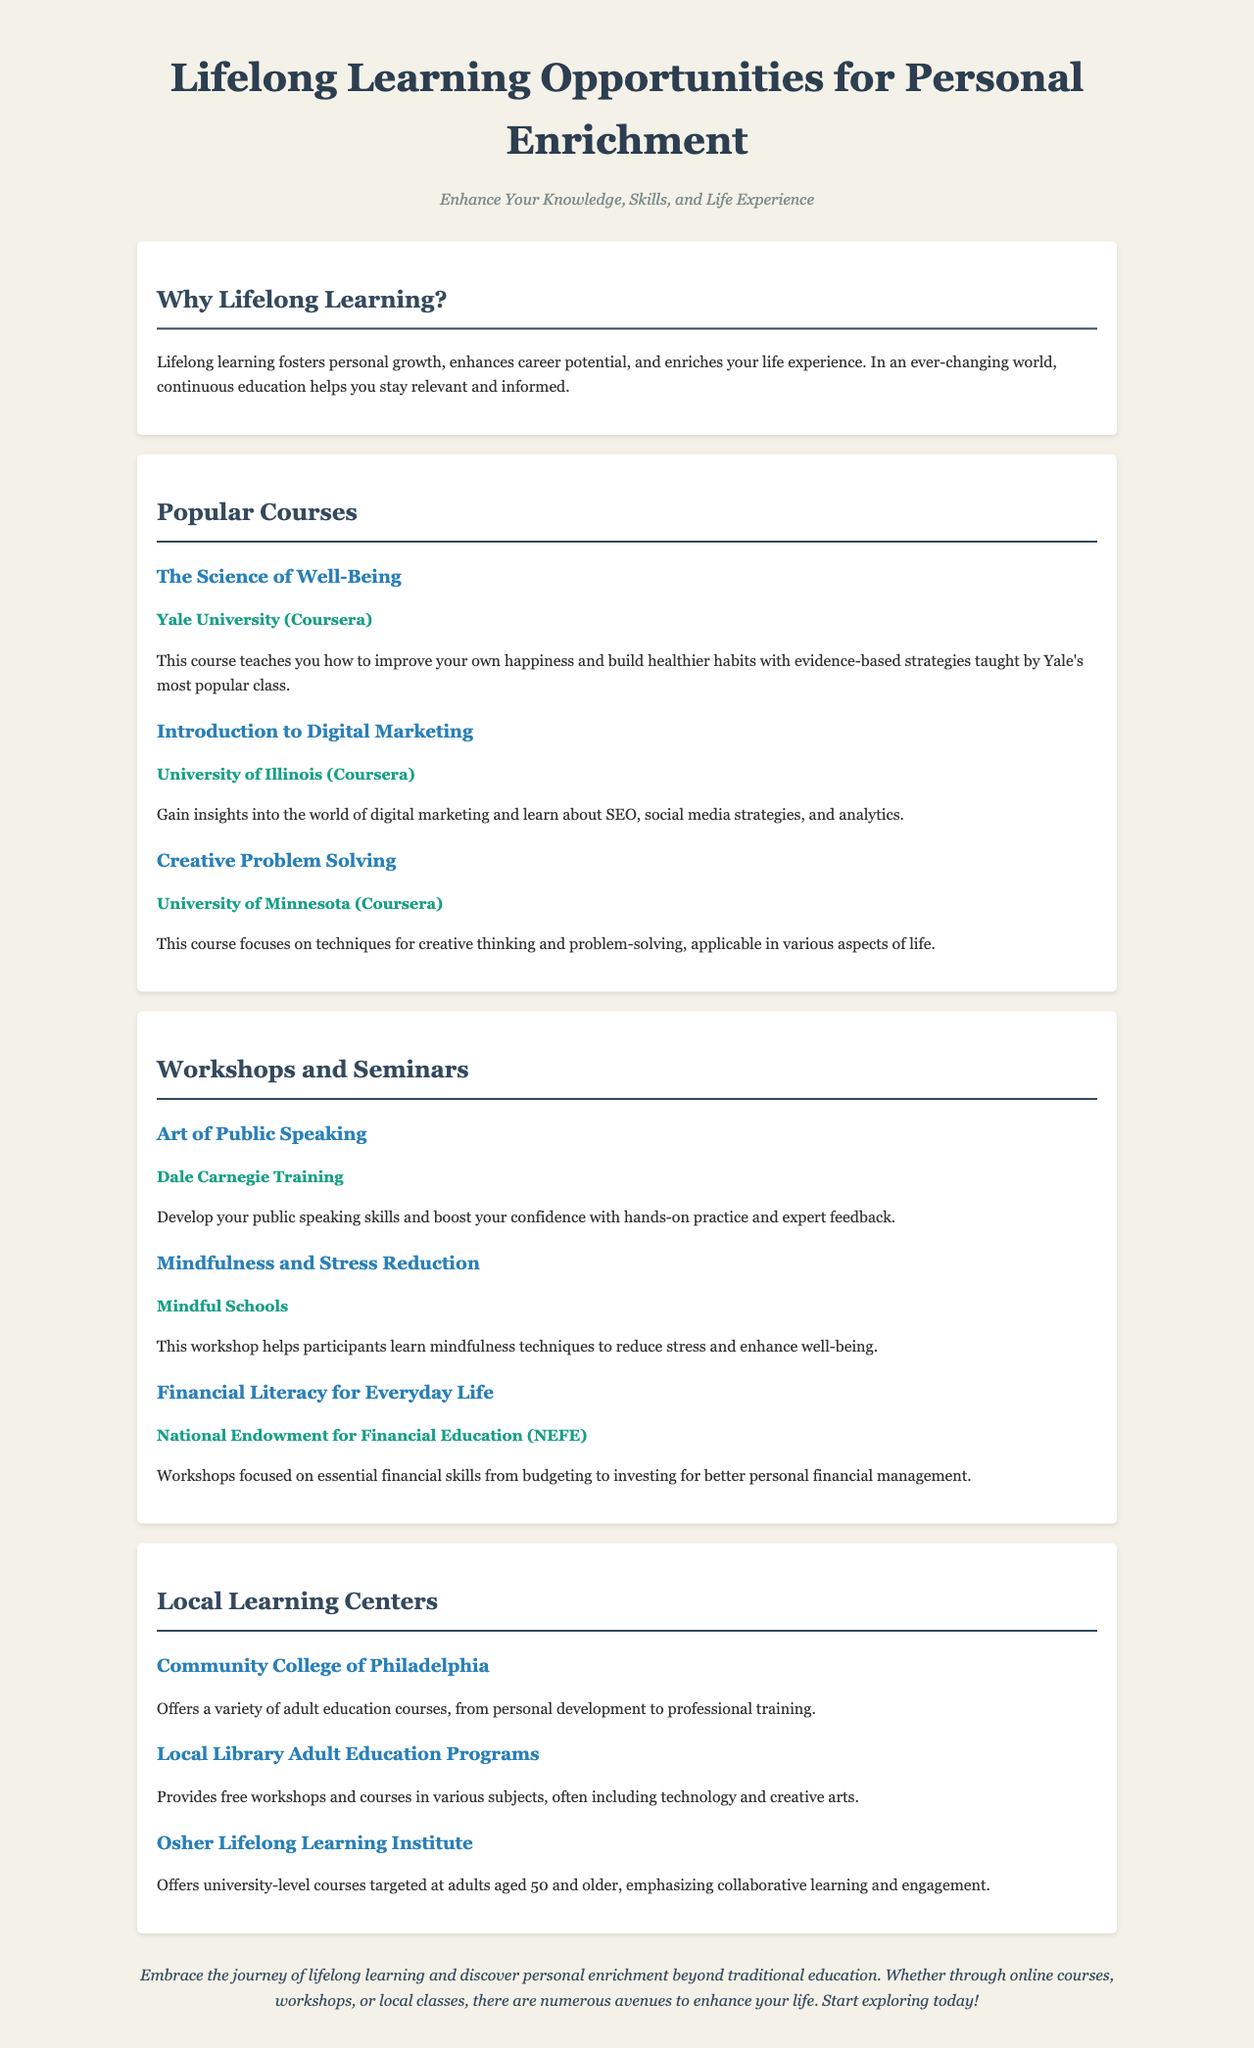What is the title of the brochure? The title is prominently displayed at the top of the document.
Answer: Lifelong Learning Opportunities for Personal Enrichment Who offers the course "The Science of Well-Being"? This information is found in the section about popular courses.
Answer: Yale University (Coursera) What topic does the workshop "Financial Literacy for Everyday Life" focus on? This topic is specified in the summary of the workshop.
Answer: Essential financial skills How many local learning centers are mentioned in the document? The document lists three different learning centers.
Answer: Three What type of learning does the Osher Lifelong Learning Institute emphasize? This is elaborated in the description of the learning center.
Answer: Collaborative learning and engagement What is the primary benefits of lifelong learning mentioned? The benefits are summarized in the section titled "Why Lifelong Learning?".
Answer: Personal growth Which course covers digital marketing insights? The specific course title can be found in the courses section.
Answer: Introduction to Digital Marketing What is the provider of the workshop "Mindfulness and Stress Reduction"? This information is clearly stated in the workshop description.
Answer: Mindful Schools 